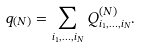Convert formula to latex. <formula><loc_0><loc_0><loc_500><loc_500>q _ { ( N ) } = \sum _ { i _ { 1 } , \dots , i _ { N } } Q _ { i _ { 1 } , \dots , i _ { N } } ^ { ( N ) } .</formula> 